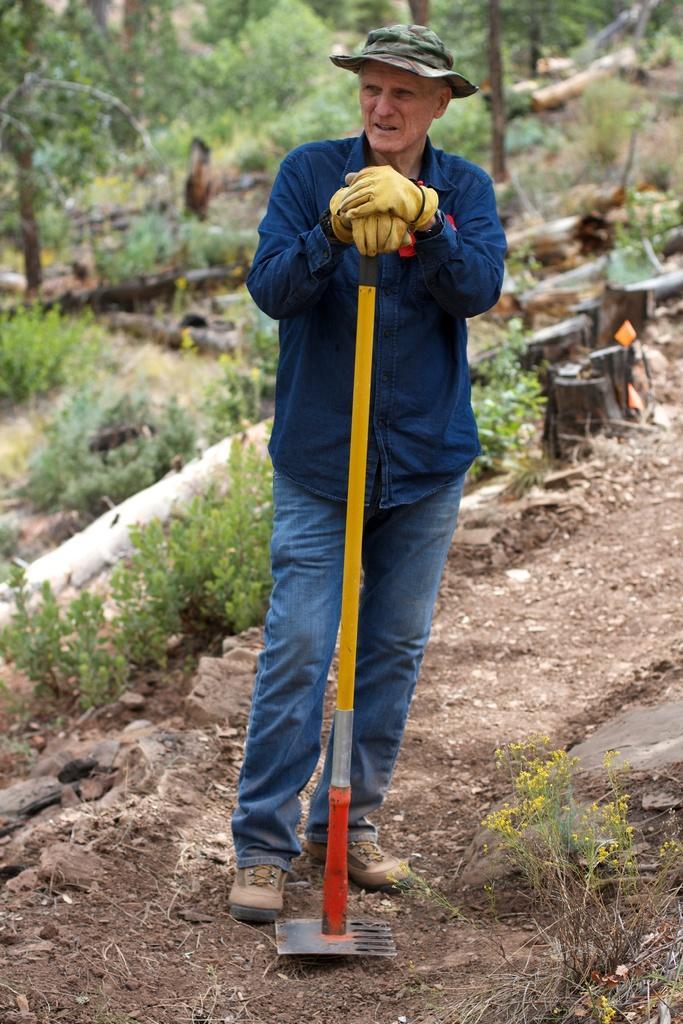In one or two sentences, can you explain what this image depicts? Here in this picture we can see a person standing on the ground over there and he is wearing gloves and hat on him and holding a stick with something below it in his hand and behind him we can see plants and trees present all over there. 